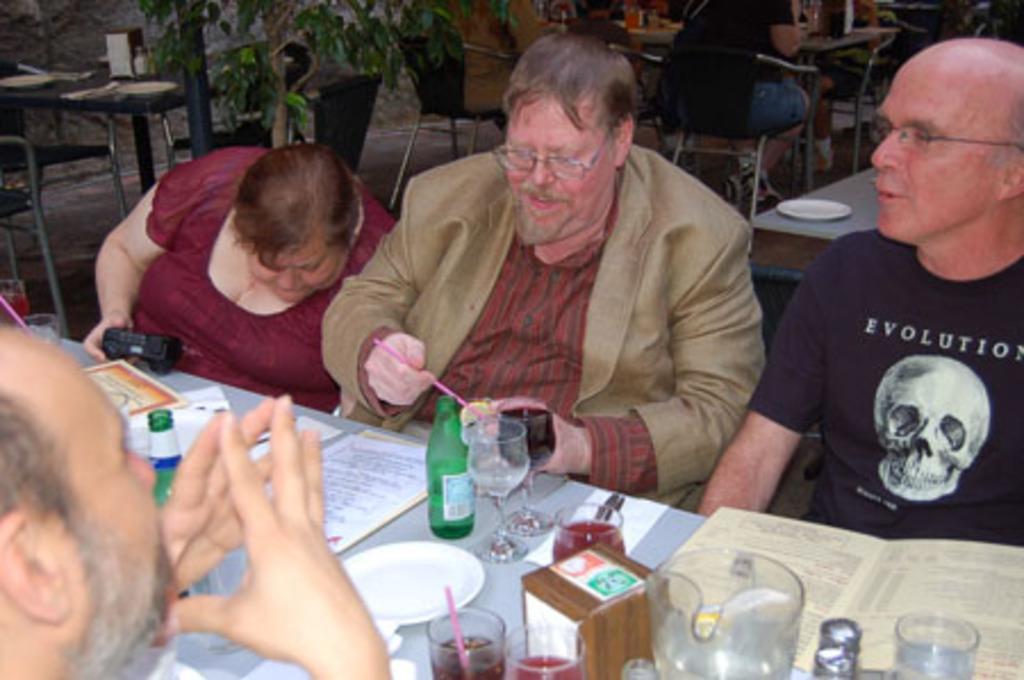In one or two sentences, can you explain what this image depicts? Three men and a woman are sitting at a table and talking among themselves. 